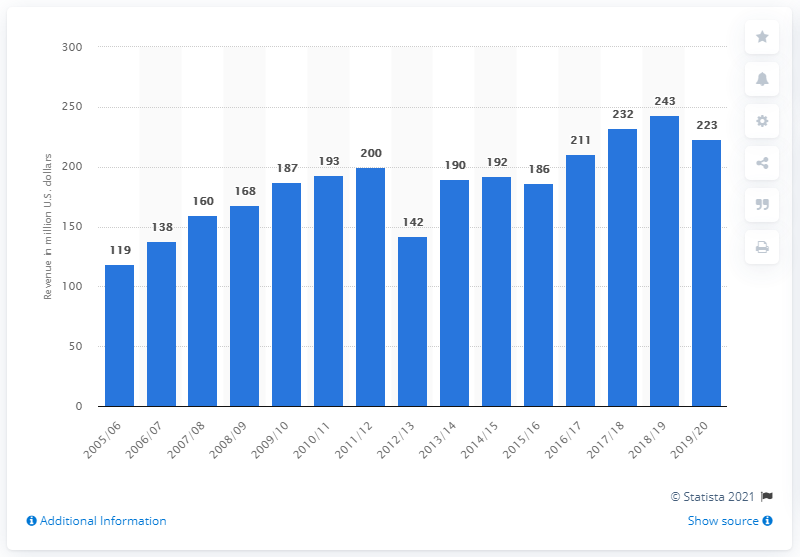Highlight a few significant elements in this photo. In the 2019/2020 season, the Toronto Maple Leafs earned 223 million dollars. In the 2019/2020 season, the Toronto Maple Leafs generated a revenue of 223 million Canadian dollars. The last season of the Toronto Maple Leafs was in the 2005/2006 season. 